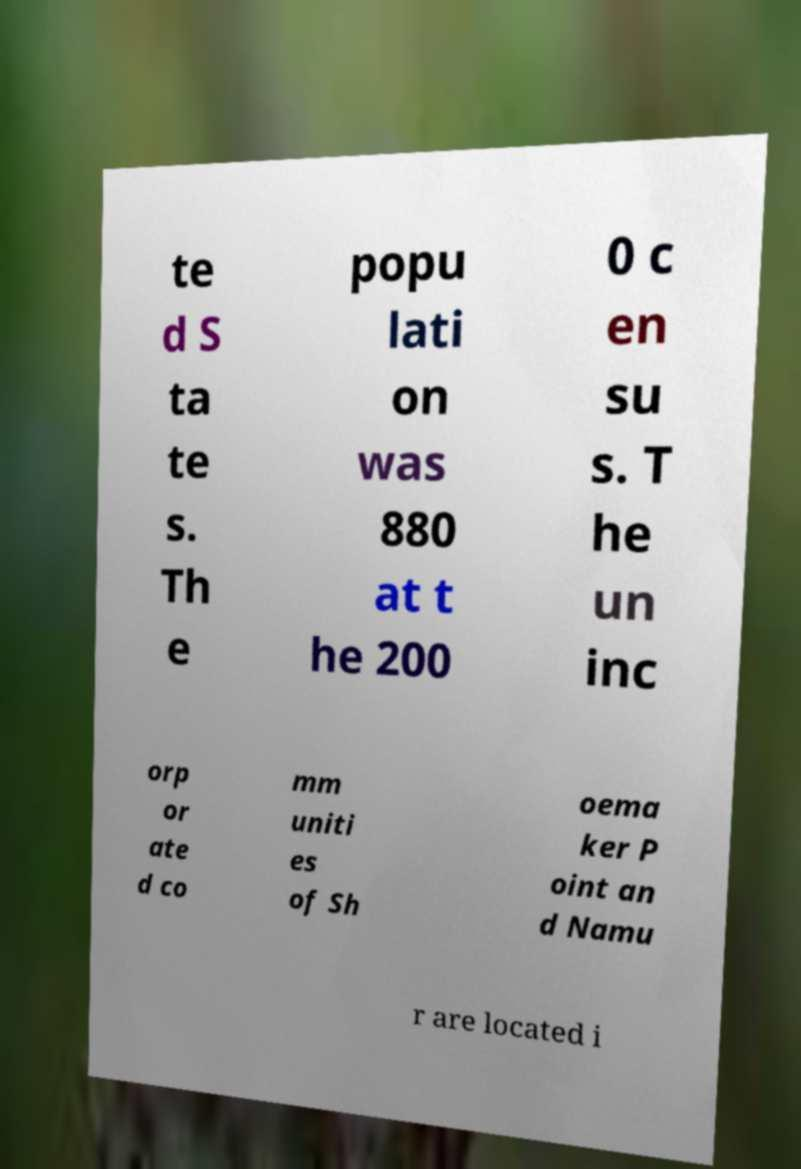I need the written content from this picture converted into text. Can you do that? te d S ta te s. Th e popu lati on was 880 at t he 200 0 c en su s. T he un inc orp or ate d co mm uniti es of Sh oema ker P oint an d Namu r are located i 